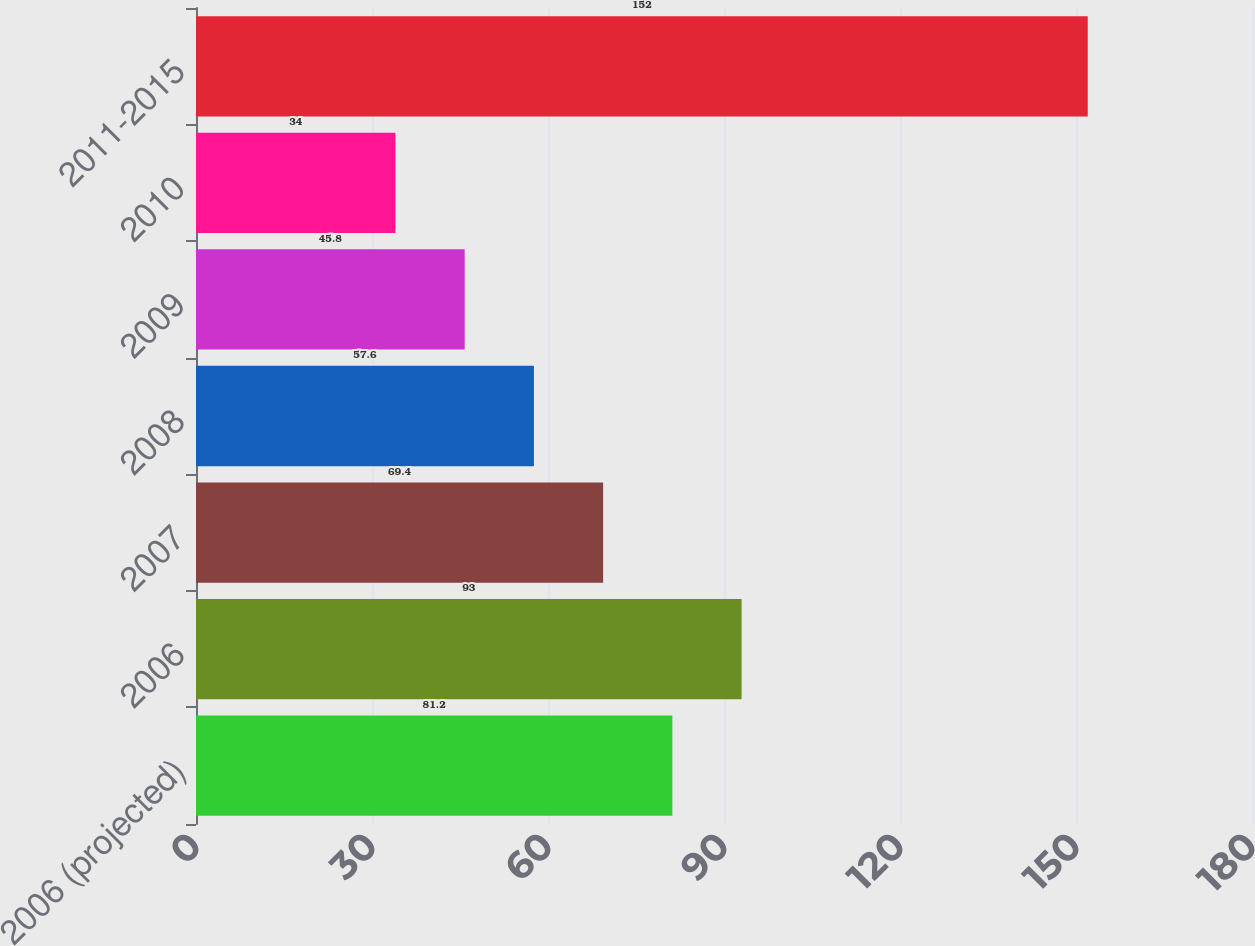<chart> <loc_0><loc_0><loc_500><loc_500><bar_chart><fcel>2006 (projected)<fcel>2006<fcel>2007<fcel>2008<fcel>2009<fcel>2010<fcel>2011-2015<nl><fcel>81.2<fcel>93<fcel>69.4<fcel>57.6<fcel>45.8<fcel>34<fcel>152<nl></chart> 